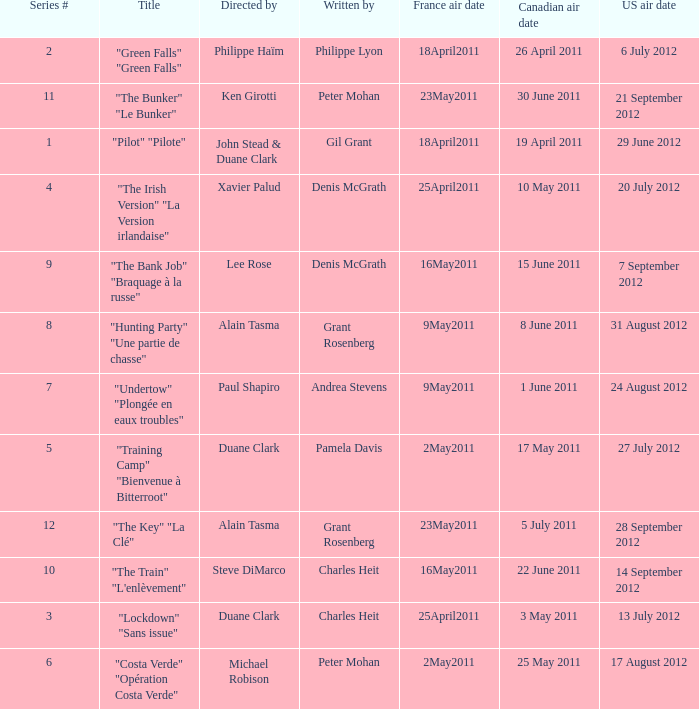What is the canadian air date when the US air date is 24 august 2012? 1 June 2011. 